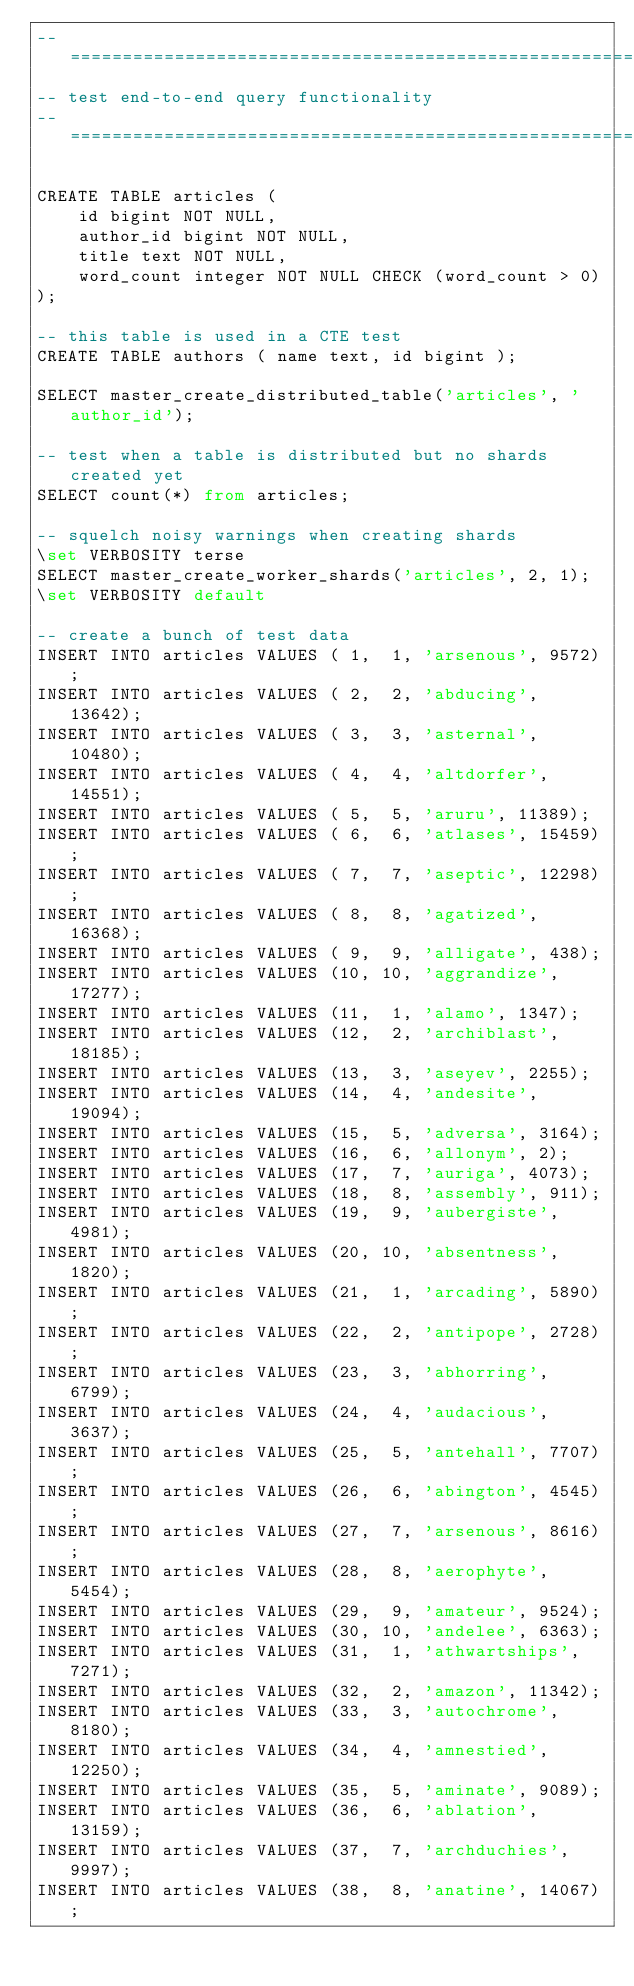<code> <loc_0><loc_0><loc_500><loc_500><_SQL_>-- ===================================================================
-- test end-to-end query functionality
-- ===================================================================

CREATE TABLE articles (
	id bigint NOT NULL,
	author_id bigint NOT NULL,
	title text NOT NULL,
	word_count integer NOT NULL CHECK (word_count > 0)
);

-- this table is used in a CTE test
CREATE TABLE authors ( name text, id bigint );

SELECT master_create_distributed_table('articles', 'author_id');

-- test when a table is distributed but no shards created yet
SELECT count(*) from articles;

-- squelch noisy warnings when creating shards
\set VERBOSITY terse
SELECT master_create_worker_shards('articles', 2, 1);
\set VERBOSITY default

-- create a bunch of test data
INSERT INTO articles VALUES ( 1,  1, 'arsenous', 9572);
INSERT INTO articles VALUES ( 2,  2, 'abducing', 13642);
INSERT INTO articles VALUES ( 3,  3, 'asternal', 10480);
INSERT INTO articles VALUES ( 4,  4, 'altdorfer', 14551);
INSERT INTO articles VALUES ( 5,  5, 'aruru', 11389);
INSERT INTO articles VALUES ( 6,  6, 'atlases', 15459);
INSERT INTO articles VALUES ( 7,  7, 'aseptic', 12298);
INSERT INTO articles VALUES ( 8,  8, 'agatized', 16368);
INSERT INTO articles VALUES ( 9,  9, 'alligate', 438);
INSERT INTO articles VALUES (10, 10, 'aggrandize', 17277);
INSERT INTO articles VALUES (11,  1, 'alamo', 1347);
INSERT INTO articles VALUES (12,  2, 'archiblast', 18185);
INSERT INTO articles VALUES (13,  3, 'aseyev', 2255);
INSERT INTO articles VALUES (14,  4, 'andesite', 19094);
INSERT INTO articles VALUES (15,  5, 'adversa', 3164);
INSERT INTO articles VALUES (16,  6, 'allonym', 2);
INSERT INTO articles VALUES (17,  7, 'auriga', 4073);
INSERT INTO articles VALUES (18,  8, 'assembly', 911);
INSERT INTO articles VALUES (19,  9, 'aubergiste', 4981);
INSERT INTO articles VALUES (20, 10, 'absentness', 1820);
INSERT INTO articles VALUES (21,  1, 'arcading', 5890);
INSERT INTO articles VALUES (22,  2, 'antipope', 2728);
INSERT INTO articles VALUES (23,  3, 'abhorring', 6799);
INSERT INTO articles VALUES (24,  4, 'audacious', 3637);
INSERT INTO articles VALUES (25,  5, 'antehall', 7707);
INSERT INTO articles VALUES (26,  6, 'abington', 4545);
INSERT INTO articles VALUES (27,  7, 'arsenous', 8616);
INSERT INTO articles VALUES (28,  8, 'aerophyte', 5454);
INSERT INTO articles VALUES (29,  9, 'amateur', 9524);
INSERT INTO articles VALUES (30, 10, 'andelee', 6363);
INSERT INTO articles VALUES (31,  1, 'athwartships', 7271);
INSERT INTO articles VALUES (32,  2, 'amazon', 11342);
INSERT INTO articles VALUES (33,  3, 'autochrome', 8180);
INSERT INTO articles VALUES (34,  4, 'amnestied', 12250);
INSERT INTO articles VALUES (35,  5, 'aminate', 9089);
INSERT INTO articles VALUES (36,  6, 'ablation', 13159);
INSERT INTO articles VALUES (37,  7, 'archduchies', 9997);
INSERT INTO articles VALUES (38,  8, 'anatine', 14067);</code> 